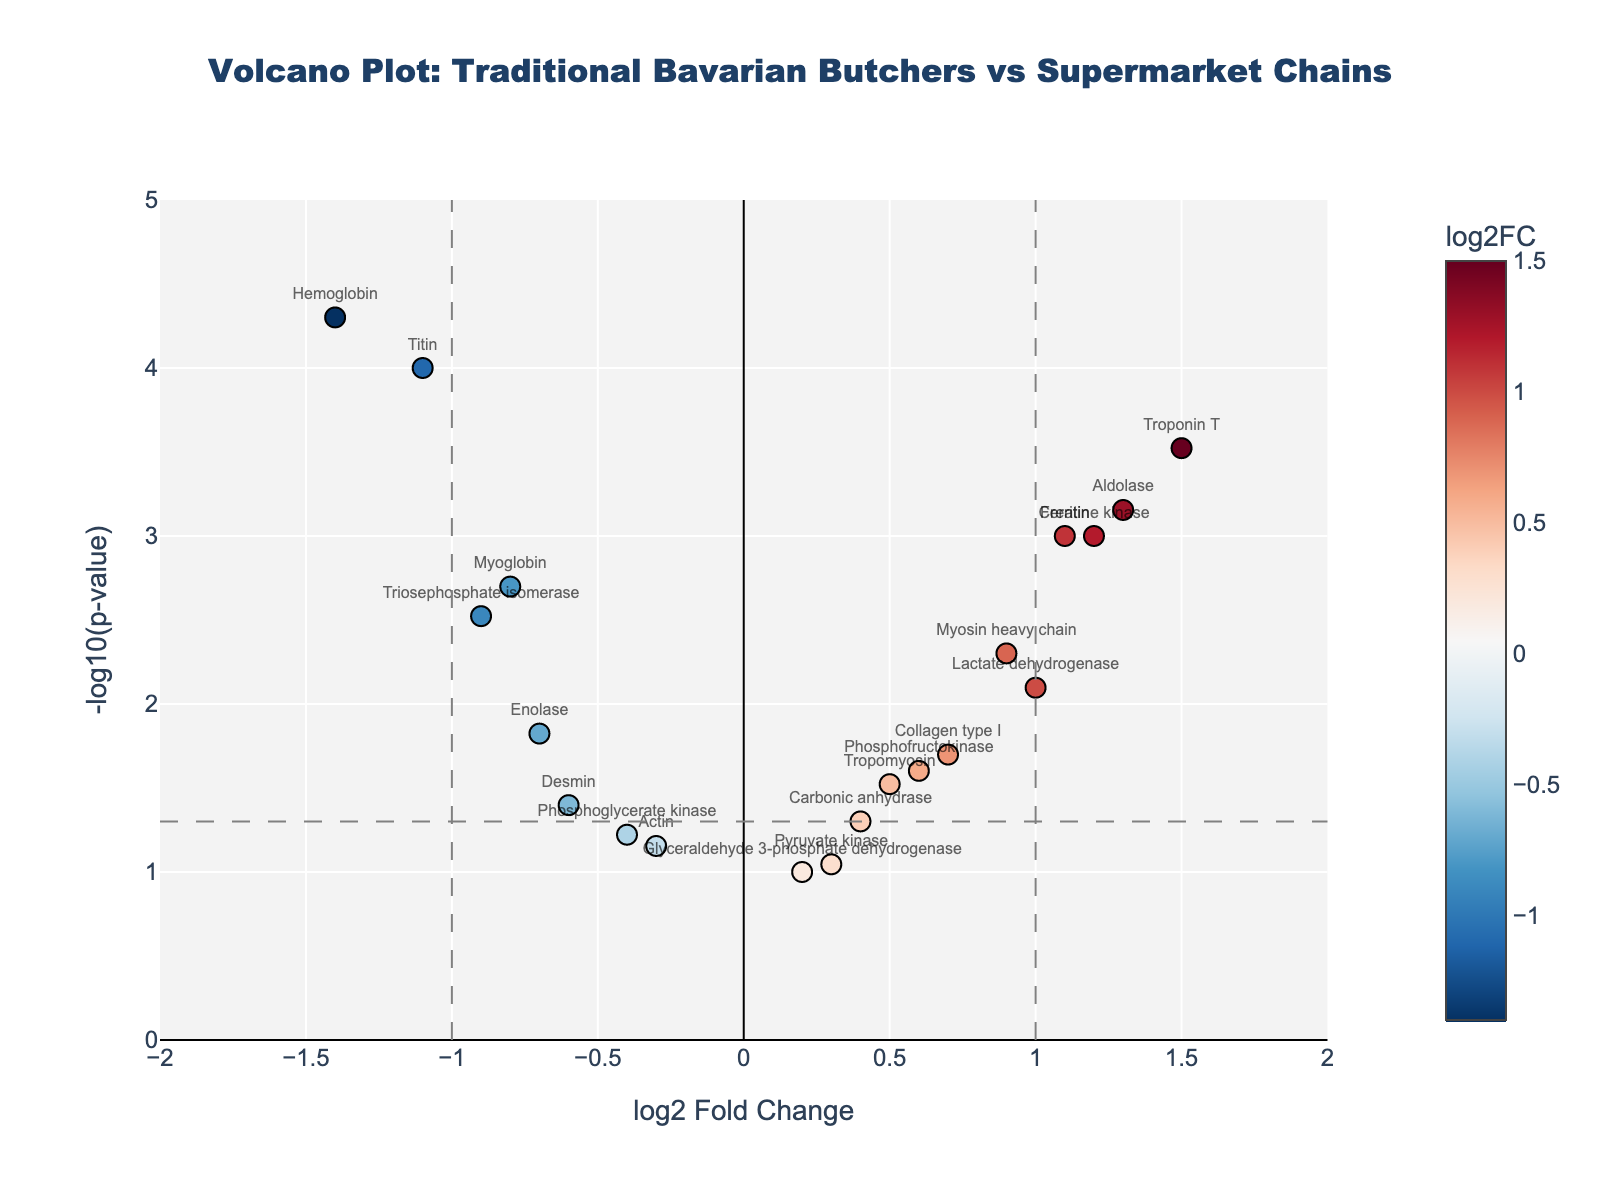How many proteins have a log2 fold change greater than 1? To find the proteins with a log2 fold change greater than 1, look at the horizontal axis and count the number of points with values above 1. There are 6 such proteins: Creatine kinase, Troponin T, Aldolase, Ferritin, Myosin heavy chain, and Lactate dehydrogenase.
Answer: 6 Which protein has the highest p-value? To find the protein with the highest p-value, look at the vertical axis where the lowest -log10(p-value) is shown. The protein with the highest p-value will correspond to the lowest y-value. Glyceraldehyde 3-phosphate dehydrogenase has the lowest y-value, around -log10(0.1).
Answer: Glyceraldehyde 3-phosphate dehydrogenase What is the log2 fold change of Hemoglobin? To determine the log2 fold change of Hemoglobin, locate its label on the scatter plot. Hemoglobin is positioned at a log2 fold change of -1.4 (on the left side of the plot).
Answer: -1.4 Which three proteins have the most significant p-values (smallest p-values)? To find the three proteins with the most significant p-values, look for the points with the highest y-values (largest -log10(p-values)). These are Hemoglobin, Titin, and Troponin T.
Answer: Hemoglobin, Titin, Troponin T Is there any protein with a log2 fold change between -0.5 and 0.5 and a p-value less than 0.05? To answer this, look for points within the log2 fold change range of -0.5 to 0.5 on the x-axis and above the horizontal line indicating -log10(p-value) > -log10(0.05). There is one such protein: Enolase (log2FC= -0.7, p-value= 0.015).
Answer: Enolase Which protein shows the highest log2 fold change and what is its p-value? To identify the protein with the highest log2 fold change, look at the rightmost points on the x-axis. Troponin T has the highest log2 fold change of 1.5, and its p-value is around 0.0003.
Answer: Troponin T, 0.0003 What is the log2 fold change of the protein with the lowest p-value? To find the protein with the lowest p-value, look for the highest y-value. Hemoglobin has the lowest p-value (highest -log10(p)) at around -1.4.
Answer: -1.4 How many proteins have a log2 fold change between -1 and 1? To find the number of proteins within a log2 fold change range of -1 to 1, count the data points between these values on the horizontal axis. There are 10 such proteins: Myoglobin, Tropomyosin, Actin, Myosin heavy chain, Desmin, Troponin T, Glyceraldehyde 3-phosphate dehydrogenase, Phosphoglycerate kinase, Pyruvate kinase, Carbonic anhydrase.
Answer: 10 